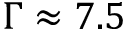Convert formula to latex. <formula><loc_0><loc_0><loc_500><loc_500>\Gamma \approx 7 . 5</formula> 